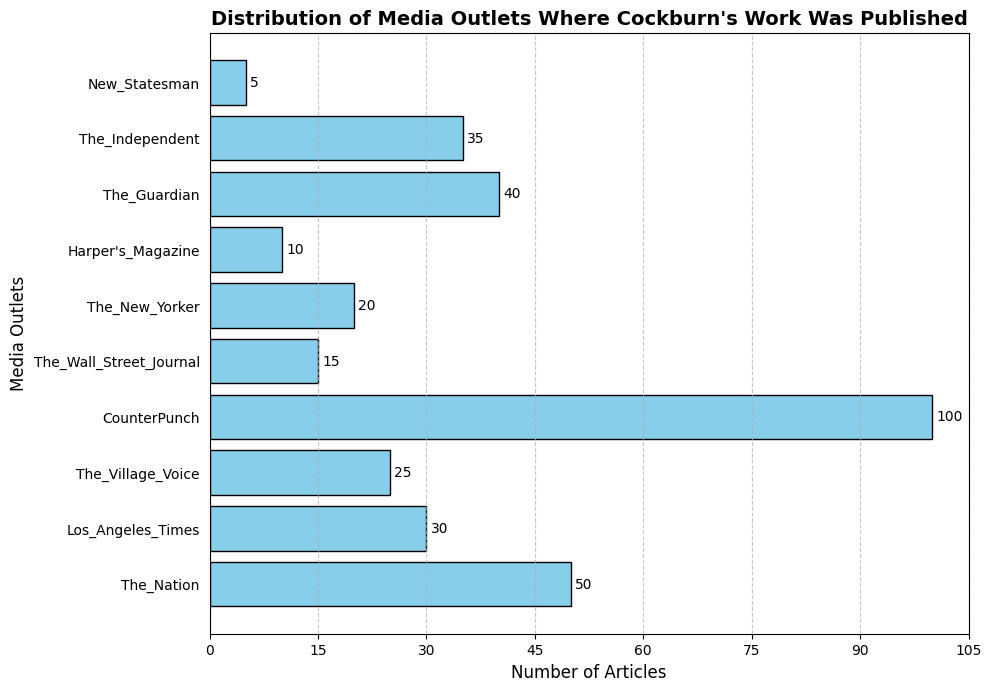Which media outlet published the most articles by Cockburn? Identify the outlet with the longest bar in the bar chart. In this case, the longest bar is for CounterPunch, which shows 100 articles.
Answer: CounterPunch Which two media outlets have the closest number of articles published by Cockburn? Compare the lengths of the bars to find the ones closest in length. The Village Voice (25 articles) and The New Yorker (20 articles) have the closest counts.
Answer: The Village Voice and The New Yorker How many more articles did The Guardian publish compared to Harper's Magazine? Subtract the number of articles published by Harper's Magazine from the number published by The Guardian. The Guardian published 40 articles and Harper's Magazine published 10, so the difference is 40 - 10 = 30.
Answer: 30 Which media outlet has published fewer articles than The Wall Street Journal but more than New Statesman? Identify outlets with article counts between 15 (The Wall Street Journal) and 5 (New Statesman). Harper's Magazine, with 10 articles, fits these criteria.
Answer: Harper's Magazine What is the combined total number of articles published by The Independent and Los Angeles Times? Add the number of articles from The Independent and Los Angeles Times. The Independent published 35 articles, and Los Angeles Times published 30, so the total is 35 + 30 = 65.
Answer: 65 How many media outlets published 25 or fewer articles by Cockburn? Count the outlets with 25 or fewer articles by examining each bar. The outlets are New Statesman (5), Harper's Magazine (10), The New Yorker (20), The Wall Street Journal (15), and The Village Voice (25), totaling 5 outlets.
Answer: 5 Is the number of articles published by CounterPunch more than three times that of The Nation? First, calculate three times the number of articles in The Nation (50 * 3 = 150). Since CounterPunch has 100 articles, it is not more than 150.
Answer: No What is the median number of articles published by all the media outlets? Arrange the values in ascending order and find the middle value. The sorted list is: 5, 10, 15, 20, 25, 30, 35, 40, 50, 100. The median is the average of the fifth and sixth values: (25 + 30) / 2 = 27.5.
Answer: 27.5 By how many articles does The Nation exceed The Wall Street Journal? Subtract the number of articles published by The Wall Street Journal from those by The Nation. The Nation has 50 articles, and The Wall Street Journal has 15. So, the difference is 50 - 15 = 35.
Answer: 35 What is the average number of articles published by all media outlets? Sum the number of articles for all outlets and divide by the number of outlets. Total articles are 50 + 30 + 25 + 100 + 15 + 20 + 10 + 40 + 35 + 5 = 330. There are 10 outlets, so the average is 330 / 10 = 33.
Answer: 33 